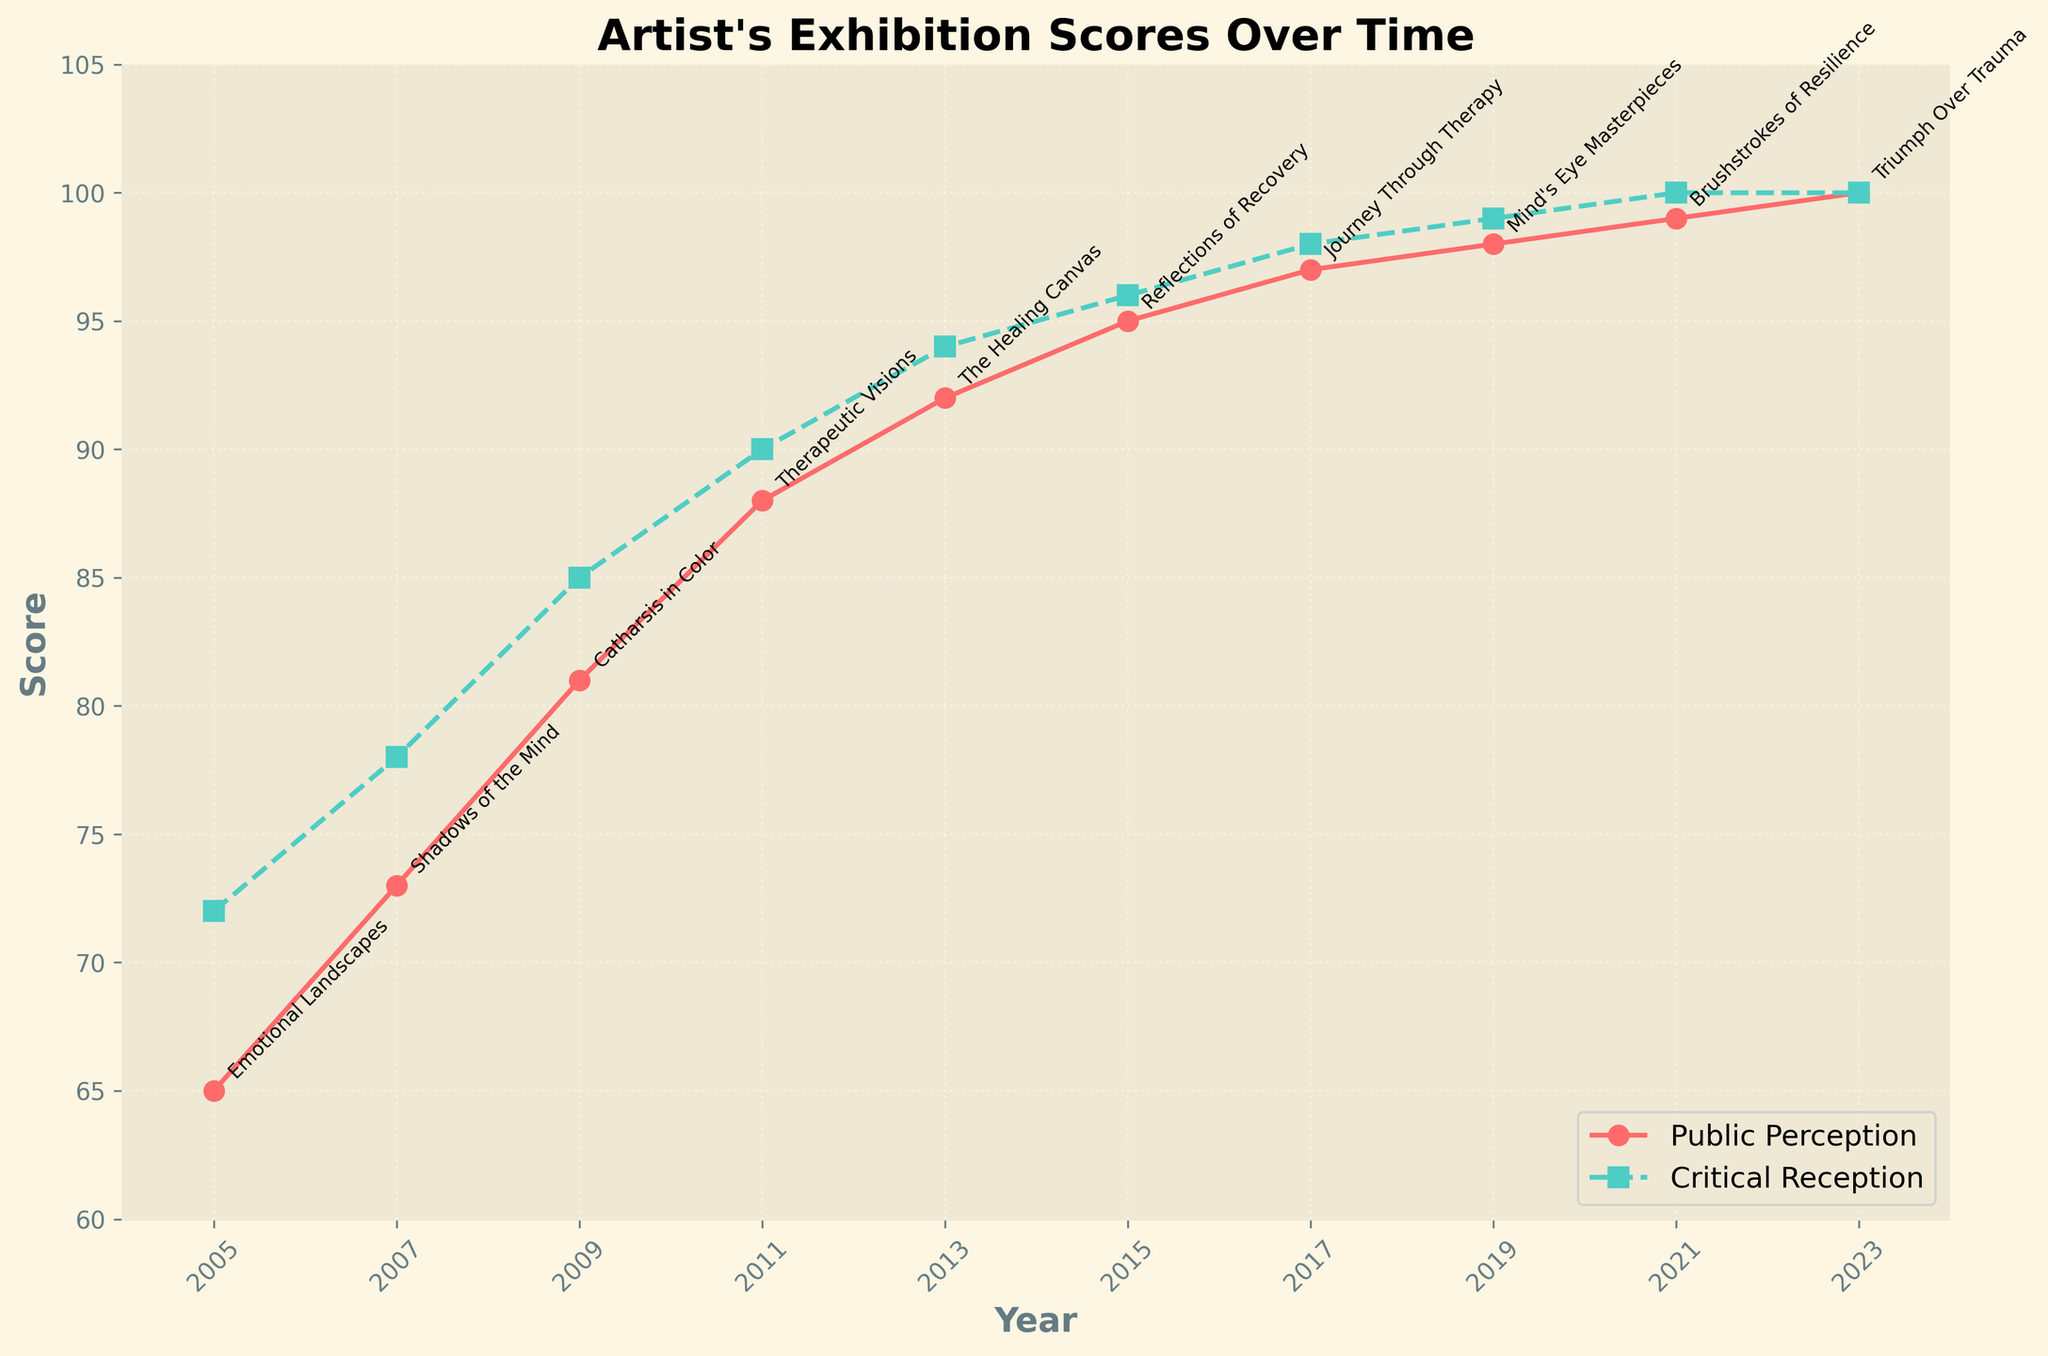What is the public perception score for the "Catharsis in Color" exhibition? Look for the data point corresponding to "Catharsis in Color" and find the public perception score on the y-axis.
Answer: 81 Which exhibition had an equal public perception and critical reception score? Identify the exhibition where both scores coincide on both lines. For "Triumph Over Trauma", both scores are 100.
Answer: "Triumph Over Trauma" What is the average public perception score from 2005 to 2013? Calculate the sum of the public perception scores from 2005 to 2013 (65, 73, 81, 88, 92) and divide by the number of scores. The sum is 399, the count is 5, so the average is 399/5.
Answer: 79.8 In which year was the gap between public perception and critical reception the largest? Compare the differences between public perception and critical reception scores for each year and identify the largest one. The largest difference is in 2005 with 7 points (72-65).
Answer: 2005 What trend do you observe in the critical reception scores throughout the artist's career? Examine the critical reception scores along the y-axis over time and note how they change. All the critic scores steadily increase over the years, showing an upward trend.
Answer: Increasing trend Which score is higher in 2019, public perception or critical reception? Directly compare the public perception and critical reception scores for the year 2019. Public perception is 98, while critical reception is 99. Hence, critical reception is higher.
Answer: Critical reception How many years did it take for the public perception score to reach 99 or higher? Identify when the public perception score first reached 99 and count the number of years from the starting point in 2005. It reached 99 in 2021; from 2005 to 2021 is 16 years.
Answer: 16 years What is the median critical reception score for the exhibitions? Arrange the critical reception scores in ascending order (72, 78, 85, 90, 94, 96, 98, 99, 100, 100) and find the middle value. The median is the average of the 5th and 6th scores (94 and 96).
Answer: 95 Compare the overall trends in public and critical reception scores. Do they follow similar patterns? Observe both lines over time and check if they show similar increases or patterns of change. Both public and critical reception scores show an overall increasing trend and follow a similar upward pattern.
Answer: Yes, similar patterns By how many points did the public perception score improve from the "Emotional Landscapes" to the "Shadows of the Mind" exhibition? Subtract the score of the first exhibition (65 in 2005) from the score of the second exhibition (73 in 2007). The improvement is 73 - 65.
Answer: 8 points 